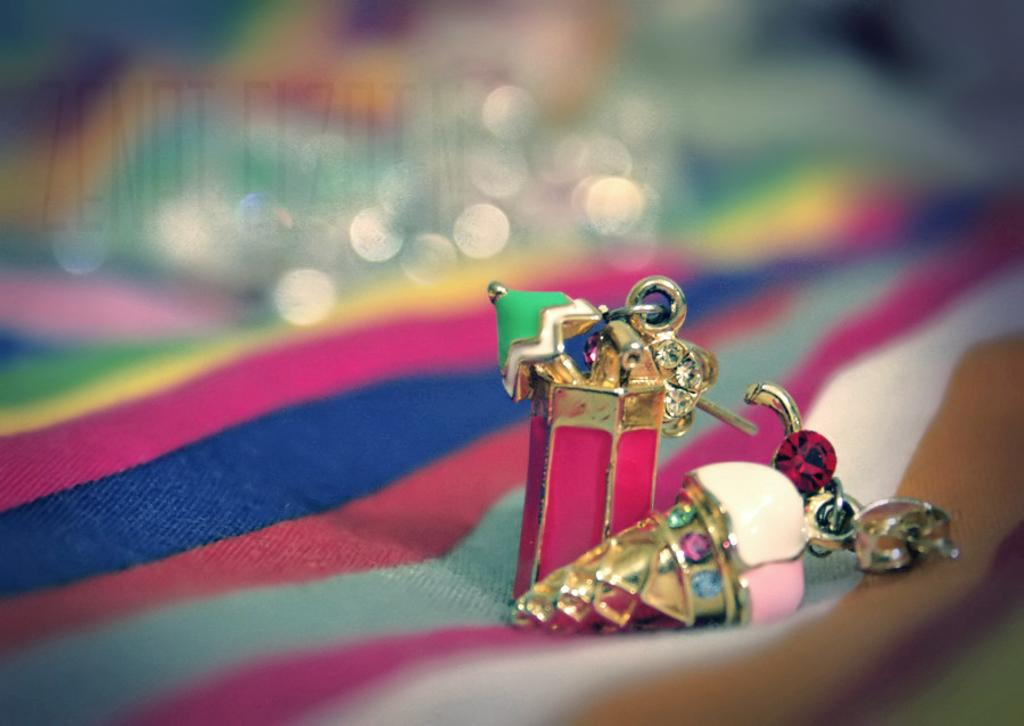What is the main subject of the image? The main subject of the image is a colorful cloth with objects on it. Can you describe the background of the image? The background of the image is blurred. What invention is being demonstrated in the image? There is no invention being demonstrated in the image; it only features a colorful cloth with objects on it and a blurred background. What type of wire can be seen connecting the objects on the cloth? There is no wire connecting the objects on the cloth in the image. 